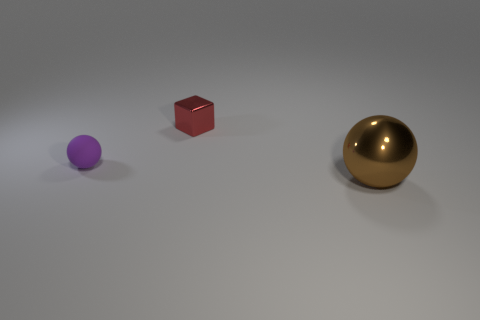Subtract 0 brown blocks. How many objects are left? 3 Subtract all blocks. How many objects are left? 2 Subtract 1 cubes. How many cubes are left? 0 Subtract all brown spheres. Subtract all blue cylinders. How many spheres are left? 1 Subtract all yellow cylinders. How many blue blocks are left? 0 Subtract all green cubes. Subtract all metal objects. How many objects are left? 1 Add 1 big shiny things. How many big shiny things are left? 2 Add 1 big brown metallic spheres. How many big brown metallic spheres exist? 2 Add 3 tiny brown metallic cubes. How many objects exist? 6 Subtract all purple balls. How many balls are left? 1 